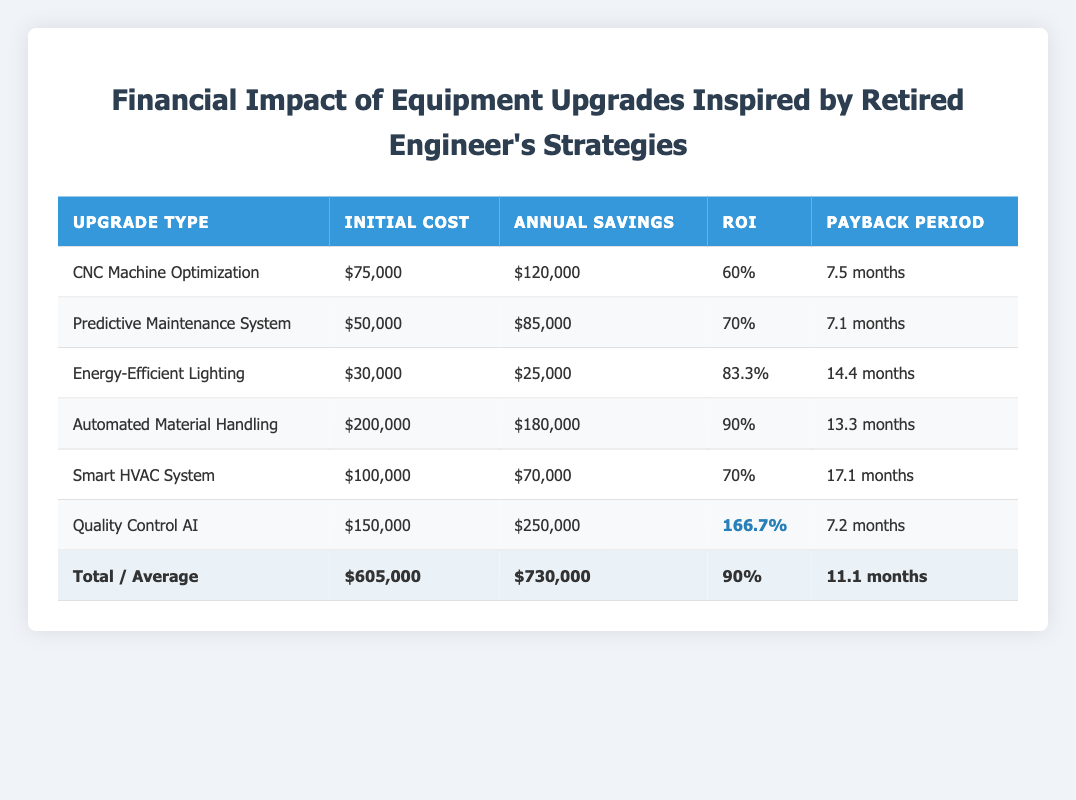What is the initial cost of the Smart HVAC System? The table lists the Smart HVAC System with an initial cost value. Referring directly to that row, the cost is displayed as 100,000.
Answer: 100,000 Which upgrade type has the highest ROI percentage? By looking at the ROI percentages for all upgrade types, the highest value is found in the Quality Control AI row, which shows an ROI of 166.7.
Answer: Quality Control AI Calculate the total annual savings from all upgrades combined. The annual savings values are listed for each type of upgrade. Summing them gives (120,000 + 85,000 + 25,000 + 180,000 + 70,000 + 250,000) = 730,000.
Answer: 730,000 Is the payback period for Automated Material Handling less than the average payback period? The payback period for Automated Material Handling is 13.3 months, while the average payback period is 11.1 months. Since 13.3 is greater than 11.1, the answer is No.
Answer: No If we compare the annual savings of Energy-Efficient Lighting and Predictive Maintenance System, which upgrade saves more annually? The annual savings for Energy-Efficient Lighting is 25,000 while for Predictive Maintenance System it is 85,000. Since 85,000 is greater than 25,000, the Predictive Maintenance System saves more.
Answer: Predictive Maintenance System What is the average ROI percentage for all upgrades? The average ROI percentage is listed at the bottom of the table, which sums up to 90. This is calculated from the individual ROI percentages across the upgrades.
Answer: 90 Does the initial cost of the CNC Machine Optimization exceed 70,000? The initial cost for CNC Machine Optimization is 75,000. Since 75,000 is greater than 70,000, the answer is Yes.
Answer: Yes What is the difference in annual savings between the Quality Control AI and the Energy-Efficient Lighting? The annual savings for Quality Control AI is 250,000 and for Energy-Efficient Lighting it is 25,000. The difference is calculated as 250,000 - 25,000 = 225,000.
Answer: 225,000 Is it true that the Smart HVAC System has a lower initial cost than the Automated Material Handling upgrade? Looking at the respective initial costs, the Smart HVAC System is 100,000 and Automated Material Handling is 200,000. Since 100,000 is less than 200,000, this statement is True.
Answer: True 